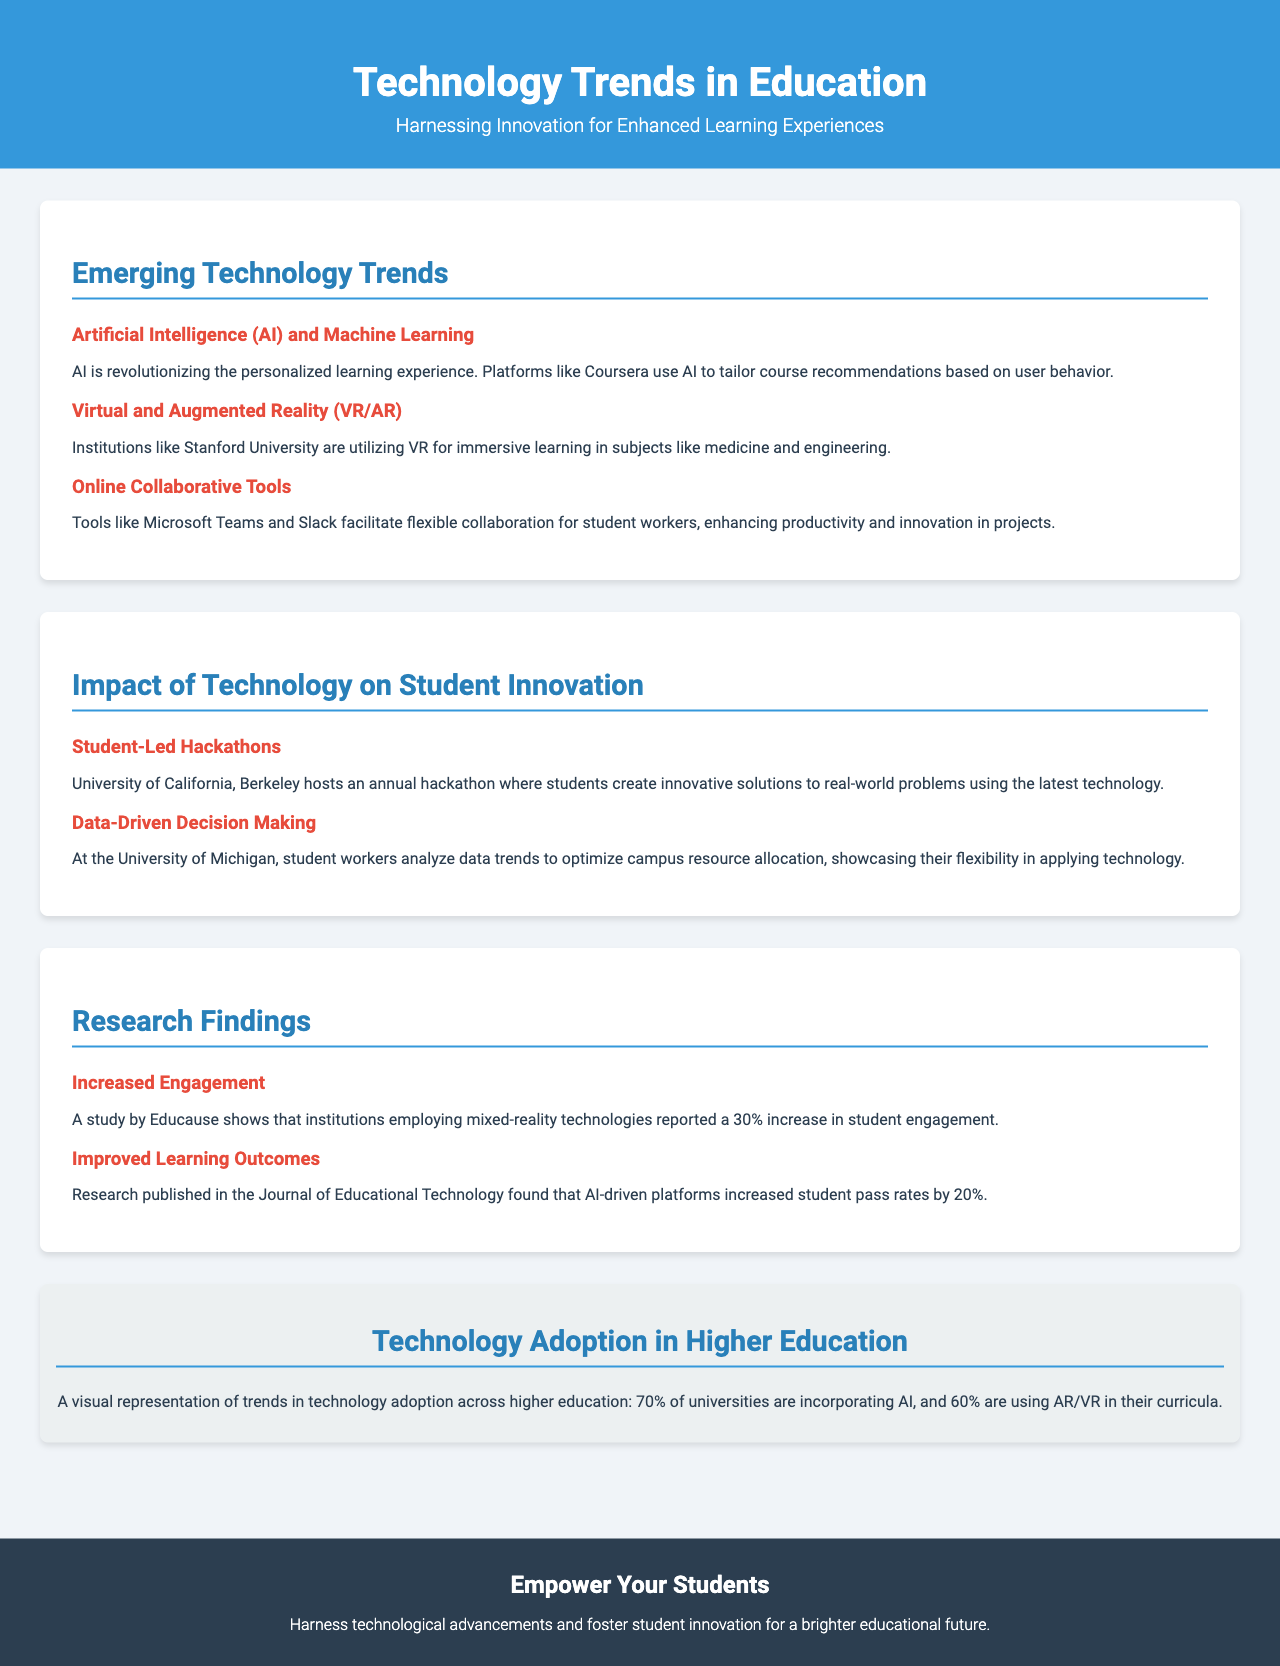What are the main emerging technology trends in education? The document lists Artificial Intelligence (AI) and Machine Learning, Virtual and Augmented Reality (VR/AR), and Online Collaborative Tools as the main emerging technology trends.
Answer: Artificial Intelligence (AI) and Machine Learning, Virtual and Augmented Reality (VR/AR), Online Collaborative Tools What percentage of universities are adopting AI technology? The infographic section reveals that 70% of universities are incorporating AI technology.
Answer: 70% What is one example of how student workers are using data at the University of Michigan? The document states that student workers analyze data trends to optimize campus resource allocation.
Answer: Optimize campus resource allocation Which university hosts an annual hackathon? The document mentions that the University of California, Berkeley hosts an annual hackathon.
Answer: University of California, Berkeley What improvement in student pass rates is associated with AI-driven platforms? According to the research findings, AI-driven platforms increased student pass rates by 20%.
Answer: 20% 